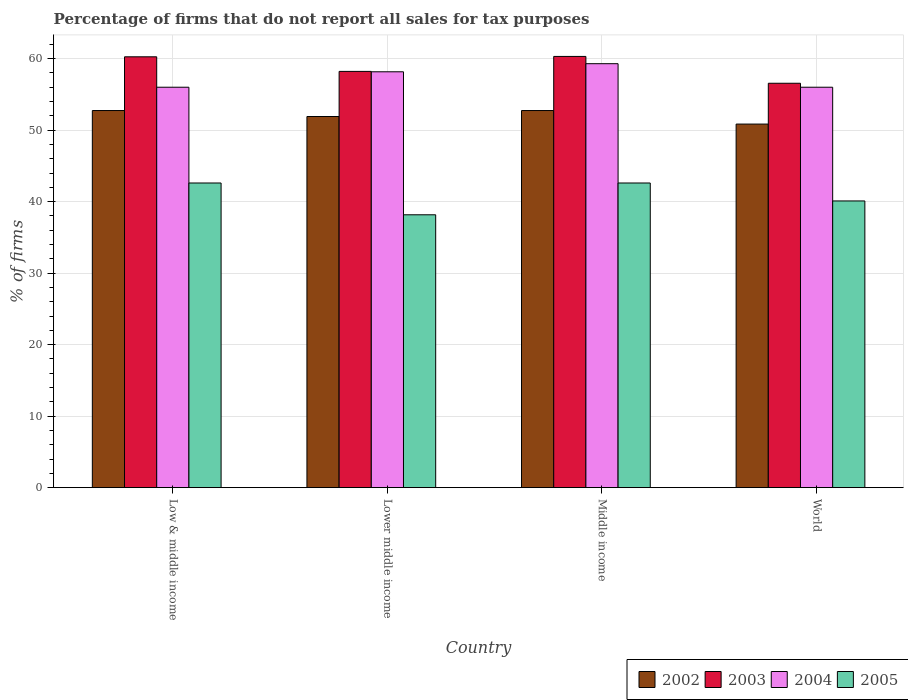How many different coloured bars are there?
Keep it short and to the point. 4. Are the number of bars on each tick of the X-axis equal?
Keep it short and to the point. Yes. How many bars are there on the 3rd tick from the right?
Ensure brevity in your answer.  4. What is the label of the 1st group of bars from the left?
Ensure brevity in your answer.  Low & middle income. What is the percentage of firms that do not report all sales for tax purposes in 2004 in Lower middle income?
Your answer should be compact. 58.16. Across all countries, what is the maximum percentage of firms that do not report all sales for tax purposes in 2002?
Offer a terse response. 52.75. Across all countries, what is the minimum percentage of firms that do not report all sales for tax purposes in 2005?
Ensure brevity in your answer.  38.16. In which country was the percentage of firms that do not report all sales for tax purposes in 2004 maximum?
Give a very brief answer. Middle income. In which country was the percentage of firms that do not report all sales for tax purposes in 2002 minimum?
Give a very brief answer. World. What is the total percentage of firms that do not report all sales for tax purposes in 2003 in the graph?
Offer a very short reply. 235.35. What is the difference between the percentage of firms that do not report all sales for tax purposes in 2005 in Low & middle income and that in World?
Offer a terse response. 2.51. What is the difference between the percentage of firms that do not report all sales for tax purposes in 2003 in Low & middle income and the percentage of firms that do not report all sales for tax purposes in 2002 in World?
Offer a very short reply. 9.41. What is the average percentage of firms that do not report all sales for tax purposes in 2004 per country?
Your answer should be very brief. 57.37. What is the difference between the percentage of firms that do not report all sales for tax purposes of/in 2003 and percentage of firms that do not report all sales for tax purposes of/in 2002 in Middle income?
Provide a succinct answer. 7.57. What is the ratio of the percentage of firms that do not report all sales for tax purposes in 2005 in Low & middle income to that in World?
Ensure brevity in your answer.  1.06. What is the difference between the highest and the second highest percentage of firms that do not report all sales for tax purposes in 2003?
Make the answer very short. -2.09. What is the difference between the highest and the lowest percentage of firms that do not report all sales for tax purposes in 2002?
Give a very brief answer. 1.89. In how many countries, is the percentage of firms that do not report all sales for tax purposes in 2003 greater than the average percentage of firms that do not report all sales for tax purposes in 2003 taken over all countries?
Your response must be concise. 2. What does the 3rd bar from the left in Middle income represents?
Provide a short and direct response. 2004. Is it the case that in every country, the sum of the percentage of firms that do not report all sales for tax purposes in 2004 and percentage of firms that do not report all sales for tax purposes in 2003 is greater than the percentage of firms that do not report all sales for tax purposes in 2005?
Keep it short and to the point. Yes. How many bars are there?
Provide a succinct answer. 16. Are the values on the major ticks of Y-axis written in scientific E-notation?
Ensure brevity in your answer.  No. Does the graph contain grids?
Make the answer very short. Yes. What is the title of the graph?
Offer a very short reply. Percentage of firms that do not report all sales for tax purposes. What is the label or title of the X-axis?
Your answer should be compact. Country. What is the label or title of the Y-axis?
Offer a terse response. % of firms. What is the % of firms of 2002 in Low & middle income?
Offer a very short reply. 52.75. What is the % of firms in 2003 in Low & middle income?
Your answer should be compact. 60.26. What is the % of firms in 2004 in Low & middle income?
Keep it short and to the point. 56.01. What is the % of firms of 2005 in Low & middle income?
Ensure brevity in your answer.  42.61. What is the % of firms of 2002 in Lower middle income?
Your answer should be compact. 51.91. What is the % of firms in 2003 in Lower middle income?
Keep it short and to the point. 58.22. What is the % of firms of 2004 in Lower middle income?
Ensure brevity in your answer.  58.16. What is the % of firms of 2005 in Lower middle income?
Keep it short and to the point. 38.16. What is the % of firms in 2002 in Middle income?
Offer a terse response. 52.75. What is the % of firms in 2003 in Middle income?
Ensure brevity in your answer.  60.31. What is the % of firms of 2004 in Middle income?
Your answer should be very brief. 59.3. What is the % of firms of 2005 in Middle income?
Your answer should be very brief. 42.61. What is the % of firms of 2002 in World?
Provide a short and direct response. 50.85. What is the % of firms in 2003 in World?
Offer a very short reply. 56.56. What is the % of firms of 2004 in World?
Your response must be concise. 56.01. What is the % of firms of 2005 in World?
Offer a terse response. 40.1. Across all countries, what is the maximum % of firms of 2002?
Provide a short and direct response. 52.75. Across all countries, what is the maximum % of firms of 2003?
Provide a short and direct response. 60.31. Across all countries, what is the maximum % of firms of 2004?
Your response must be concise. 59.3. Across all countries, what is the maximum % of firms of 2005?
Keep it short and to the point. 42.61. Across all countries, what is the minimum % of firms in 2002?
Keep it short and to the point. 50.85. Across all countries, what is the minimum % of firms of 2003?
Keep it short and to the point. 56.56. Across all countries, what is the minimum % of firms in 2004?
Provide a short and direct response. 56.01. Across all countries, what is the minimum % of firms in 2005?
Make the answer very short. 38.16. What is the total % of firms in 2002 in the graph?
Make the answer very short. 208.25. What is the total % of firms in 2003 in the graph?
Make the answer very short. 235.35. What is the total % of firms in 2004 in the graph?
Offer a terse response. 229.47. What is the total % of firms of 2005 in the graph?
Ensure brevity in your answer.  163.48. What is the difference between the % of firms in 2002 in Low & middle income and that in Lower middle income?
Offer a terse response. 0.84. What is the difference between the % of firms in 2003 in Low & middle income and that in Lower middle income?
Offer a terse response. 2.04. What is the difference between the % of firms in 2004 in Low & middle income and that in Lower middle income?
Give a very brief answer. -2.16. What is the difference between the % of firms of 2005 in Low & middle income and that in Lower middle income?
Your answer should be compact. 4.45. What is the difference between the % of firms of 2003 in Low & middle income and that in Middle income?
Your response must be concise. -0.05. What is the difference between the % of firms of 2004 in Low & middle income and that in Middle income?
Offer a terse response. -3.29. What is the difference between the % of firms in 2002 in Low & middle income and that in World?
Your answer should be compact. 1.89. What is the difference between the % of firms of 2004 in Low & middle income and that in World?
Offer a very short reply. 0. What is the difference between the % of firms of 2005 in Low & middle income and that in World?
Your response must be concise. 2.51. What is the difference between the % of firms in 2002 in Lower middle income and that in Middle income?
Provide a succinct answer. -0.84. What is the difference between the % of firms of 2003 in Lower middle income and that in Middle income?
Ensure brevity in your answer.  -2.09. What is the difference between the % of firms in 2004 in Lower middle income and that in Middle income?
Provide a short and direct response. -1.13. What is the difference between the % of firms of 2005 in Lower middle income and that in Middle income?
Your response must be concise. -4.45. What is the difference between the % of firms in 2002 in Lower middle income and that in World?
Provide a succinct answer. 1.06. What is the difference between the % of firms in 2003 in Lower middle income and that in World?
Provide a succinct answer. 1.66. What is the difference between the % of firms in 2004 in Lower middle income and that in World?
Keep it short and to the point. 2.16. What is the difference between the % of firms in 2005 in Lower middle income and that in World?
Ensure brevity in your answer.  -1.94. What is the difference between the % of firms of 2002 in Middle income and that in World?
Provide a short and direct response. 1.89. What is the difference between the % of firms of 2003 in Middle income and that in World?
Keep it short and to the point. 3.75. What is the difference between the % of firms of 2004 in Middle income and that in World?
Provide a short and direct response. 3.29. What is the difference between the % of firms in 2005 in Middle income and that in World?
Offer a terse response. 2.51. What is the difference between the % of firms of 2002 in Low & middle income and the % of firms of 2003 in Lower middle income?
Ensure brevity in your answer.  -5.47. What is the difference between the % of firms of 2002 in Low & middle income and the % of firms of 2004 in Lower middle income?
Provide a succinct answer. -5.42. What is the difference between the % of firms in 2002 in Low & middle income and the % of firms in 2005 in Lower middle income?
Your response must be concise. 14.58. What is the difference between the % of firms in 2003 in Low & middle income and the % of firms in 2004 in Lower middle income?
Give a very brief answer. 2.1. What is the difference between the % of firms of 2003 in Low & middle income and the % of firms of 2005 in Lower middle income?
Provide a short and direct response. 22.1. What is the difference between the % of firms of 2004 in Low & middle income and the % of firms of 2005 in Lower middle income?
Make the answer very short. 17.84. What is the difference between the % of firms of 2002 in Low & middle income and the % of firms of 2003 in Middle income?
Your answer should be very brief. -7.57. What is the difference between the % of firms of 2002 in Low & middle income and the % of firms of 2004 in Middle income?
Provide a short and direct response. -6.55. What is the difference between the % of firms of 2002 in Low & middle income and the % of firms of 2005 in Middle income?
Ensure brevity in your answer.  10.13. What is the difference between the % of firms in 2003 in Low & middle income and the % of firms in 2005 in Middle income?
Your answer should be compact. 17.65. What is the difference between the % of firms of 2004 in Low & middle income and the % of firms of 2005 in Middle income?
Your response must be concise. 13.39. What is the difference between the % of firms in 2002 in Low & middle income and the % of firms in 2003 in World?
Make the answer very short. -3.81. What is the difference between the % of firms in 2002 in Low & middle income and the % of firms in 2004 in World?
Your response must be concise. -3.26. What is the difference between the % of firms in 2002 in Low & middle income and the % of firms in 2005 in World?
Offer a very short reply. 12.65. What is the difference between the % of firms of 2003 in Low & middle income and the % of firms of 2004 in World?
Ensure brevity in your answer.  4.25. What is the difference between the % of firms in 2003 in Low & middle income and the % of firms in 2005 in World?
Your answer should be compact. 20.16. What is the difference between the % of firms in 2004 in Low & middle income and the % of firms in 2005 in World?
Keep it short and to the point. 15.91. What is the difference between the % of firms in 2002 in Lower middle income and the % of firms in 2003 in Middle income?
Ensure brevity in your answer.  -8.4. What is the difference between the % of firms in 2002 in Lower middle income and the % of firms in 2004 in Middle income?
Offer a very short reply. -7.39. What is the difference between the % of firms in 2002 in Lower middle income and the % of firms in 2005 in Middle income?
Provide a succinct answer. 9.3. What is the difference between the % of firms in 2003 in Lower middle income and the % of firms in 2004 in Middle income?
Your answer should be compact. -1.08. What is the difference between the % of firms of 2003 in Lower middle income and the % of firms of 2005 in Middle income?
Your answer should be compact. 15.61. What is the difference between the % of firms of 2004 in Lower middle income and the % of firms of 2005 in Middle income?
Provide a short and direct response. 15.55. What is the difference between the % of firms of 2002 in Lower middle income and the % of firms of 2003 in World?
Provide a succinct answer. -4.65. What is the difference between the % of firms in 2002 in Lower middle income and the % of firms in 2004 in World?
Your response must be concise. -4.1. What is the difference between the % of firms of 2002 in Lower middle income and the % of firms of 2005 in World?
Your response must be concise. 11.81. What is the difference between the % of firms in 2003 in Lower middle income and the % of firms in 2004 in World?
Your response must be concise. 2.21. What is the difference between the % of firms in 2003 in Lower middle income and the % of firms in 2005 in World?
Offer a terse response. 18.12. What is the difference between the % of firms in 2004 in Lower middle income and the % of firms in 2005 in World?
Your answer should be very brief. 18.07. What is the difference between the % of firms in 2002 in Middle income and the % of firms in 2003 in World?
Offer a very short reply. -3.81. What is the difference between the % of firms of 2002 in Middle income and the % of firms of 2004 in World?
Offer a terse response. -3.26. What is the difference between the % of firms of 2002 in Middle income and the % of firms of 2005 in World?
Offer a terse response. 12.65. What is the difference between the % of firms in 2003 in Middle income and the % of firms in 2004 in World?
Provide a succinct answer. 4.31. What is the difference between the % of firms in 2003 in Middle income and the % of firms in 2005 in World?
Give a very brief answer. 20.21. What is the difference between the % of firms of 2004 in Middle income and the % of firms of 2005 in World?
Your answer should be very brief. 19.2. What is the average % of firms in 2002 per country?
Keep it short and to the point. 52.06. What is the average % of firms in 2003 per country?
Offer a terse response. 58.84. What is the average % of firms of 2004 per country?
Your answer should be very brief. 57.37. What is the average % of firms in 2005 per country?
Keep it short and to the point. 40.87. What is the difference between the % of firms in 2002 and % of firms in 2003 in Low & middle income?
Provide a short and direct response. -7.51. What is the difference between the % of firms of 2002 and % of firms of 2004 in Low & middle income?
Your answer should be very brief. -3.26. What is the difference between the % of firms of 2002 and % of firms of 2005 in Low & middle income?
Your answer should be compact. 10.13. What is the difference between the % of firms in 2003 and % of firms in 2004 in Low & middle income?
Your response must be concise. 4.25. What is the difference between the % of firms of 2003 and % of firms of 2005 in Low & middle income?
Provide a short and direct response. 17.65. What is the difference between the % of firms of 2004 and % of firms of 2005 in Low & middle income?
Ensure brevity in your answer.  13.39. What is the difference between the % of firms in 2002 and % of firms in 2003 in Lower middle income?
Make the answer very short. -6.31. What is the difference between the % of firms of 2002 and % of firms of 2004 in Lower middle income?
Ensure brevity in your answer.  -6.26. What is the difference between the % of firms in 2002 and % of firms in 2005 in Lower middle income?
Give a very brief answer. 13.75. What is the difference between the % of firms in 2003 and % of firms in 2004 in Lower middle income?
Give a very brief answer. 0.05. What is the difference between the % of firms of 2003 and % of firms of 2005 in Lower middle income?
Your answer should be compact. 20.06. What is the difference between the % of firms of 2004 and % of firms of 2005 in Lower middle income?
Ensure brevity in your answer.  20. What is the difference between the % of firms in 2002 and % of firms in 2003 in Middle income?
Make the answer very short. -7.57. What is the difference between the % of firms in 2002 and % of firms in 2004 in Middle income?
Provide a succinct answer. -6.55. What is the difference between the % of firms of 2002 and % of firms of 2005 in Middle income?
Your answer should be compact. 10.13. What is the difference between the % of firms of 2003 and % of firms of 2004 in Middle income?
Give a very brief answer. 1.02. What is the difference between the % of firms in 2003 and % of firms in 2005 in Middle income?
Provide a short and direct response. 17.7. What is the difference between the % of firms of 2004 and % of firms of 2005 in Middle income?
Keep it short and to the point. 16.69. What is the difference between the % of firms in 2002 and % of firms in 2003 in World?
Provide a succinct answer. -5.71. What is the difference between the % of firms in 2002 and % of firms in 2004 in World?
Make the answer very short. -5.15. What is the difference between the % of firms in 2002 and % of firms in 2005 in World?
Ensure brevity in your answer.  10.75. What is the difference between the % of firms of 2003 and % of firms of 2004 in World?
Provide a succinct answer. 0.56. What is the difference between the % of firms in 2003 and % of firms in 2005 in World?
Keep it short and to the point. 16.46. What is the difference between the % of firms of 2004 and % of firms of 2005 in World?
Your answer should be very brief. 15.91. What is the ratio of the % of firms in 2002 in Low & middle income to that in Lower middle income?
Your answer should be compact. 1.02. What is the ratio of the % of firms in 2003 in Low & middle income to that in Lower middle income?
Your answer should be very brief. 1.04. What is the ratio of the % of firms of 2004 in Low & middle income to that in Lower middle income?
Offer a very short reply. 0.96. What is the ratio of the % of firms in 2005 in Low & middle income to that in Lower middle income?
Provide a succinct answer. 1.12. What is the ratio of the % of firms of 2002 in Low & middle income to that in Middle income?
Provide a short and direct response. 1. What is the ratio of the % of firms of 2004 in Low & middle income to that in Middle income?
Provide a short and direct response. 0.94. What is the ratio of the % of firms of 2005 in Low & middle income to that in Middle income?
Provide a succinct answer. 1. What is the ratio of the % of firms of 2002 in Low & middle income to that in World?
Provide a succinct answer. 1.04. What is the ratio of the % of firms of 2003 in Low & middle income to that in World?
Ensure brevity in your answer.  1.07. What is the ratio of the % of firms of 2005 in Low & middle income to that in World?
Give a very brief answer. 1.06. What is the ratio of the % of firms in 2002 in Lower middle income to that in Middle income?
Give a very brief answer. 0.98. What is the ratio of the % of firms of 2003 in Lower middle income to that in Middle income?
Your answer should be compact. 0.97. What is the ratio of the % of firms of 2004 in Lower middle income to that in Middle income?
Your response must be concise. 0.98. What is the ratio of the % of firms of 2005 in Lower middle income to that in Middle income?
Provide a short and direct response. 0.9. What is the ratio of the % of firms in 2002 in Lower middle income to that in World?
Keep it short and to the point. 1.02. What is the ratio of the % of firms in 2003 in Lower middle income to that in World?
Make the answer very short. 1.03. What is the ratio of the % of firms of 2004 in Lower middle income to that in World?
Your response must be concise. 1.04. What is the ratio of the % of firms of 2005 in Lower middle income to that in World?
Ensure brevity in your answer.  0.95. What is the ratio of the % of firms in 2002 in Middle income to that in World?
Offer a terse response. 1.04. What is the ratio of the % of firms in 2003 in Middle income to that in World?
Provide a short and direct response. 1.07. What is the ratio of the % of firms in 2004 in Middle income to that in World?
Your response must be concise. 1.06. What is the ratio of the % of firms in 2005 in Middle income to that in World?
Offer a terse response. 1.06. What is the difference between the highest and the second highest % of firms in 2003?
Your answer should be very brief. 0.05. What is the difference between the highest and the second highest % of firms in 2004?
Keep it short and to the point. 1.13. What is the difference between the highest and the lowest % of firms of 2002?
Your response must be concise. 1.89. What is the difference between the highest and the lowest % of firms of 2003?
Ensure brevity in your answer.  3.75. What is the difference between the highest and the lowest % of firms of 2004?
Your response must be concise. 3.29. What is the difference between the highest and the lowest % of firms of 2005?
Your response must be concise. 4.45. 